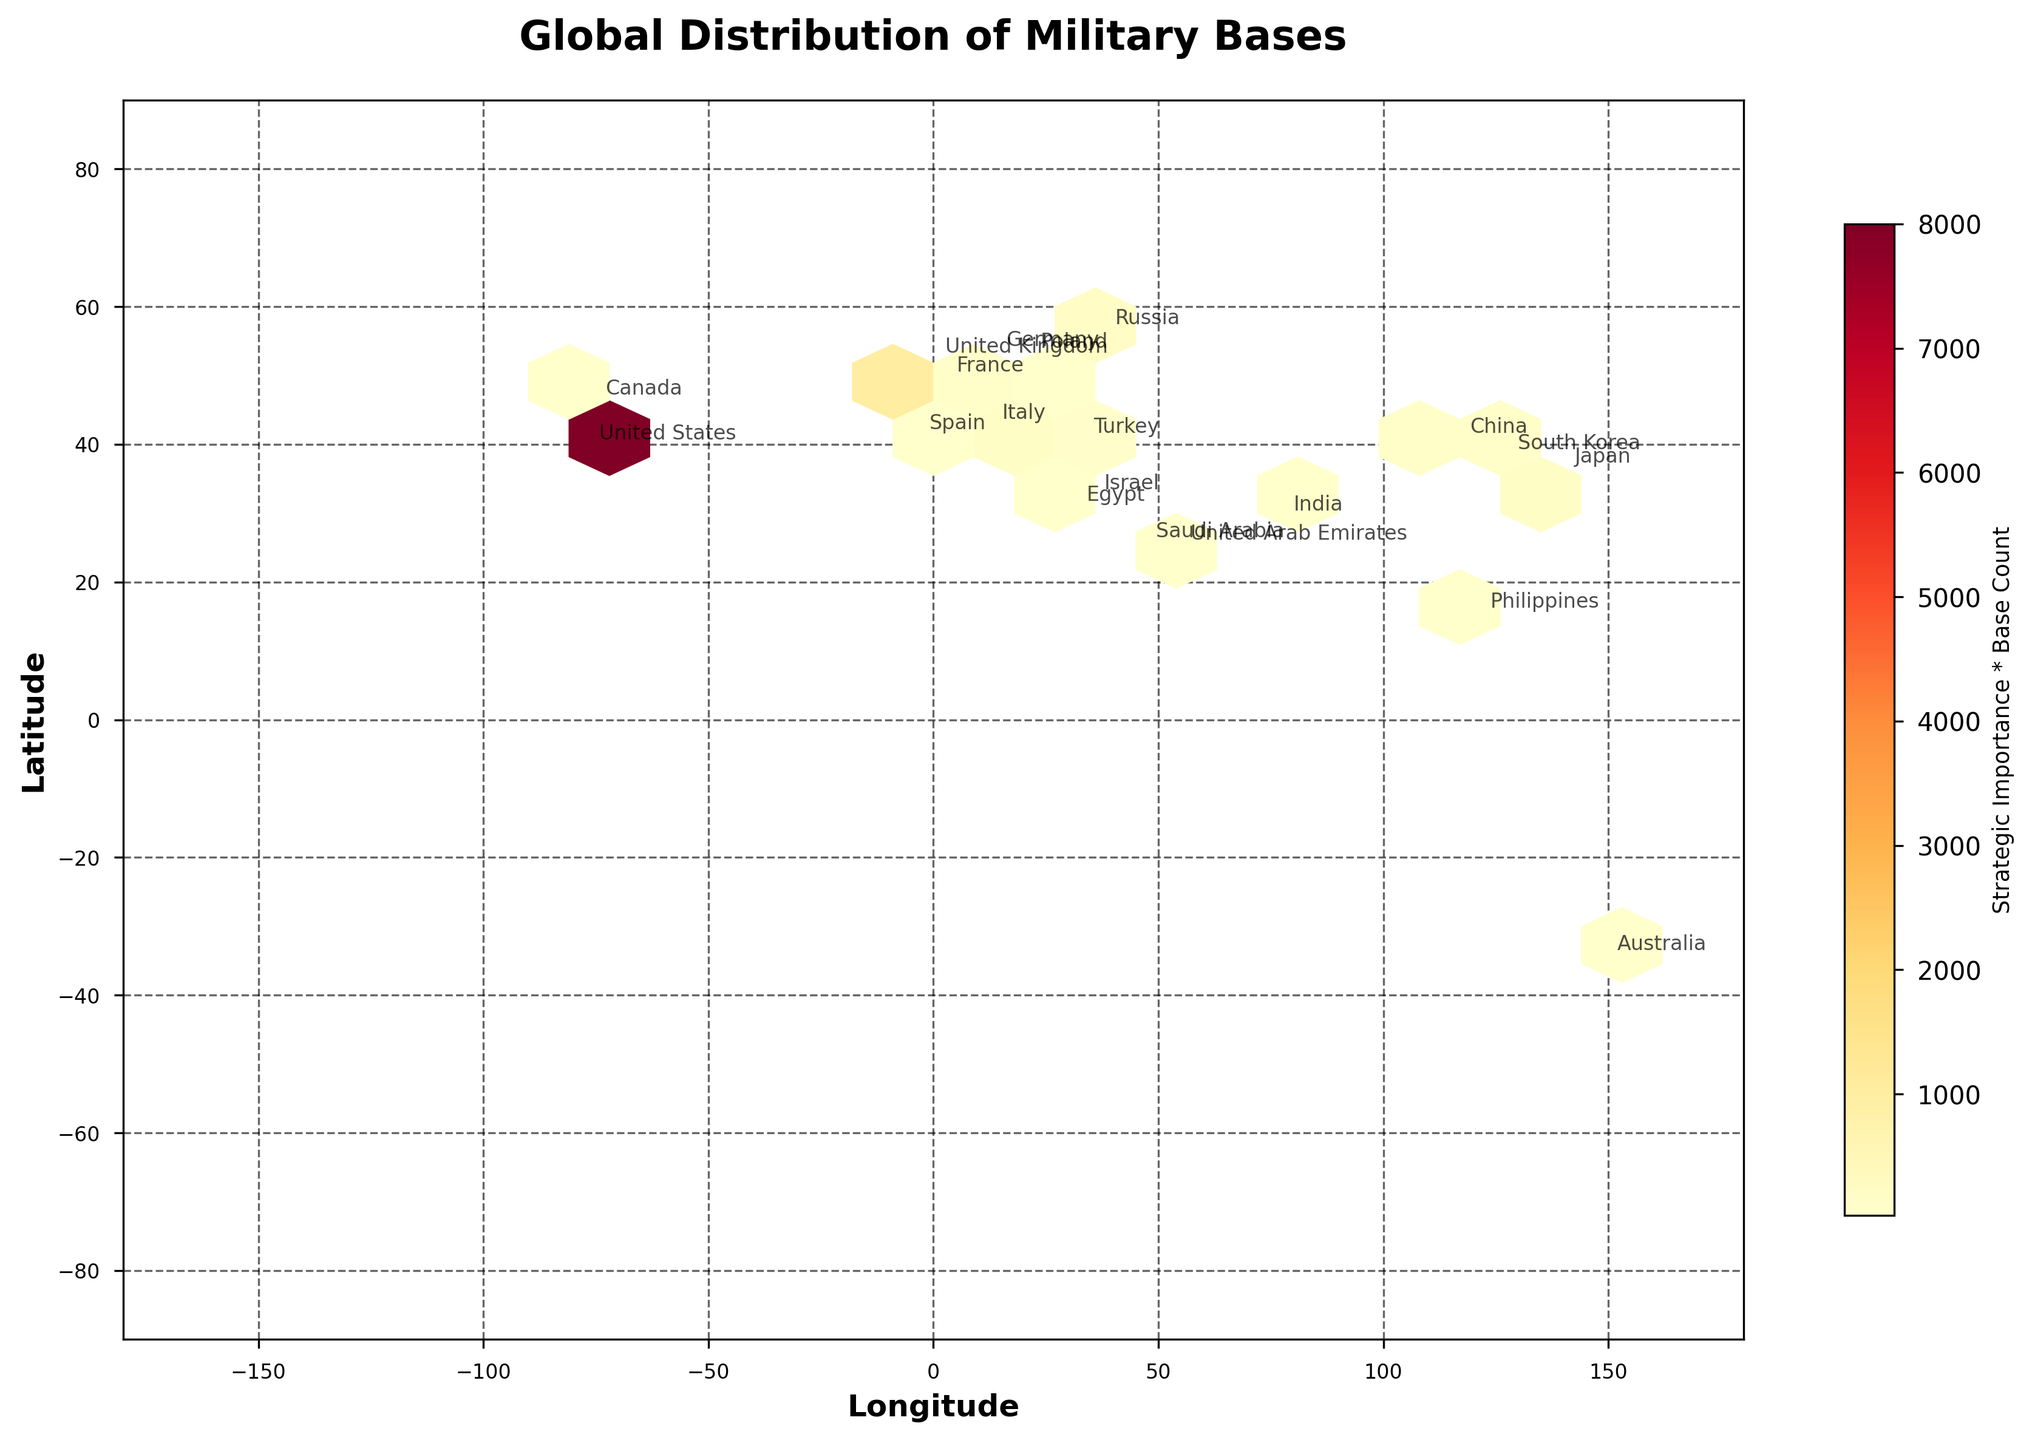What does the title of the plot say? The title of a plot usually indicates what the plot is about. In this case, it is stated at the top.
Answer: "Global Distribution of Military Bases" What does the color intensity represent in this hexbin plot? The color intensity in a hexbin plot typically represents the density or value of data points in that hexagon. Here, it shows the product of strategic importance and base count, as indicated by the color bar.
Answer: Strategic Importance * Base Count What geographic regions show the highest concentration of strategically important military bases? Areas with greater color intensity on the plot are the regions with the highest concentration. In this figure, the regions around the United States, Europe, and East Asia have the highest concentrations.
Answer: United States, Europe, East Asia Which country is located at the coordinates approximately (38.9, -77.0)? By looking at the annotations near these coordinates, we can identify the corresponding country. In this case, it is labeled next to these coordinates.
Answer: United States What is the approximate latitude and longitude of the military bases in Japan? The exact position can be seen from the country annotation near the coordinates. Japan is located around (35.6, 139.7) in the figure.
Answer: (35.6, 139.7) Which countries have more than 20 military bases and higher strategic importance, as visible in the plot? A country with a larger number of bases and higher strategic importance would have a higher color intensity in specific regions. The plot shows clear annotations for the United States, United Kingdom, Germany, and Japan.
Answer: United States, United Kingdom, Germany, Japan How does the density of military bases in Europe compare to that in the Middle East? By examining the color intensity and the number of annotations in Europe and the Middle East, we can compare the density. Europe appears to have a higher density with more annotations than the Middle East.
Answer: Higher in Europe Which two countries are closest in terms of geographic location and appear with similar base density in the plot? By looking at adjacent countries with similar hexbin color intensities, Italy and Germany in Europe share similar characteristics.
Answer: Italy and Germany Is there a significant difference between the strategic importance of bases in North America and East Asia? By comparing the color intensities representing the product of strategic importance and base count, North America (United States) shows significantly higher values than East Asia (China and Japan).
Answer: Yes, significantly higher in North America 